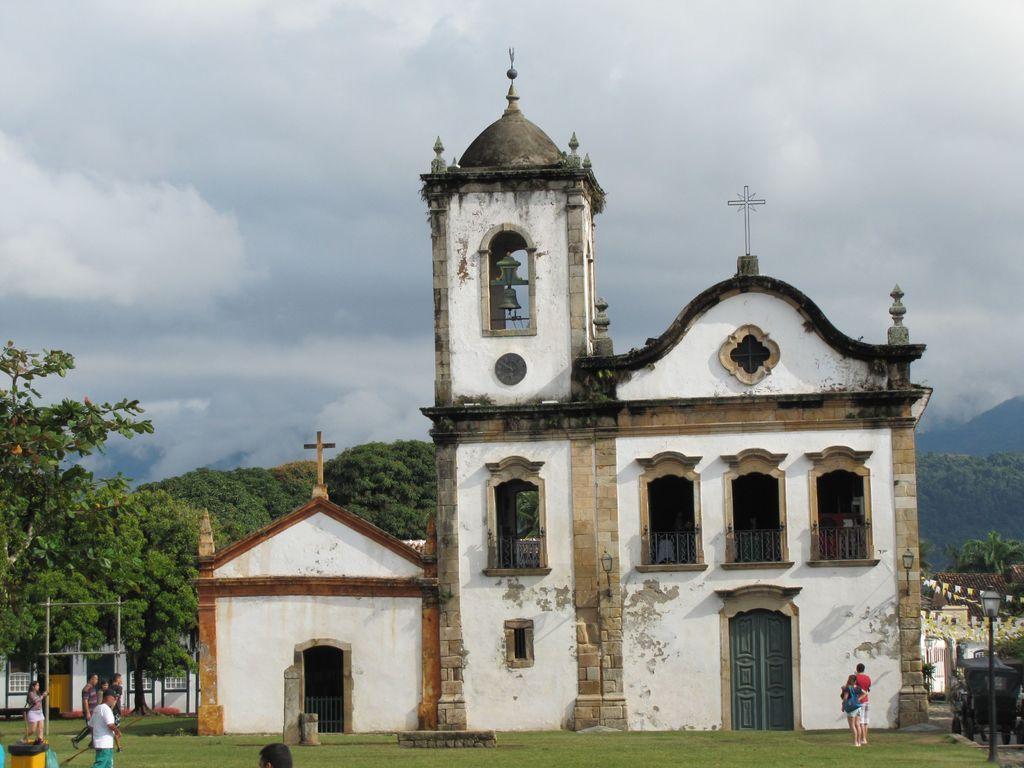Can you describe this image briefly? In this image we can see a church with grills, doors and lights, there are some people walking on the grass, we can see some trees and a pole, in the background we can see the sky. 